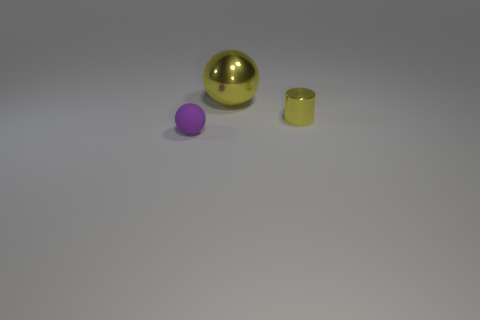There is a yellow shiny object that is right of the yellow metal sphere; what is its shape?
Make the answer very short. Cylinder. There is a small object that is to the right of the big metallic thing; does it have the same color as the small rubber ball?
Ensure brevity in your answer.  No. Are there fewer tiny purple things right of the tiny metal object than big yellow shiny cylinders?
Ensure brevity in your answer.  No. There is another thing that is the same material as the small yellow thing; what is its color?
Offer a very short reply. Yellow. What is the size of the ball behind the purple matte thing?
Your answer should be compact. Large. Is the yellow sphere made of the same material as the purple object?
Make the answer very short. No. Is there a sphere in front of the shiny thing on the left side of the object that is to the right of the big metal sphere?
Give a very brief answer. Yes. The big object is what color?
Give a very brief answer. Yellow. There is a matte object that is the same size as the yellow metal cylinder; what color is it?
Make the answer very short. Purple. Is the shape of the tiny object that is on the left side of the tiny yellow cylinder the same as  the large thing?
Your answer should be very brief. Yes. 